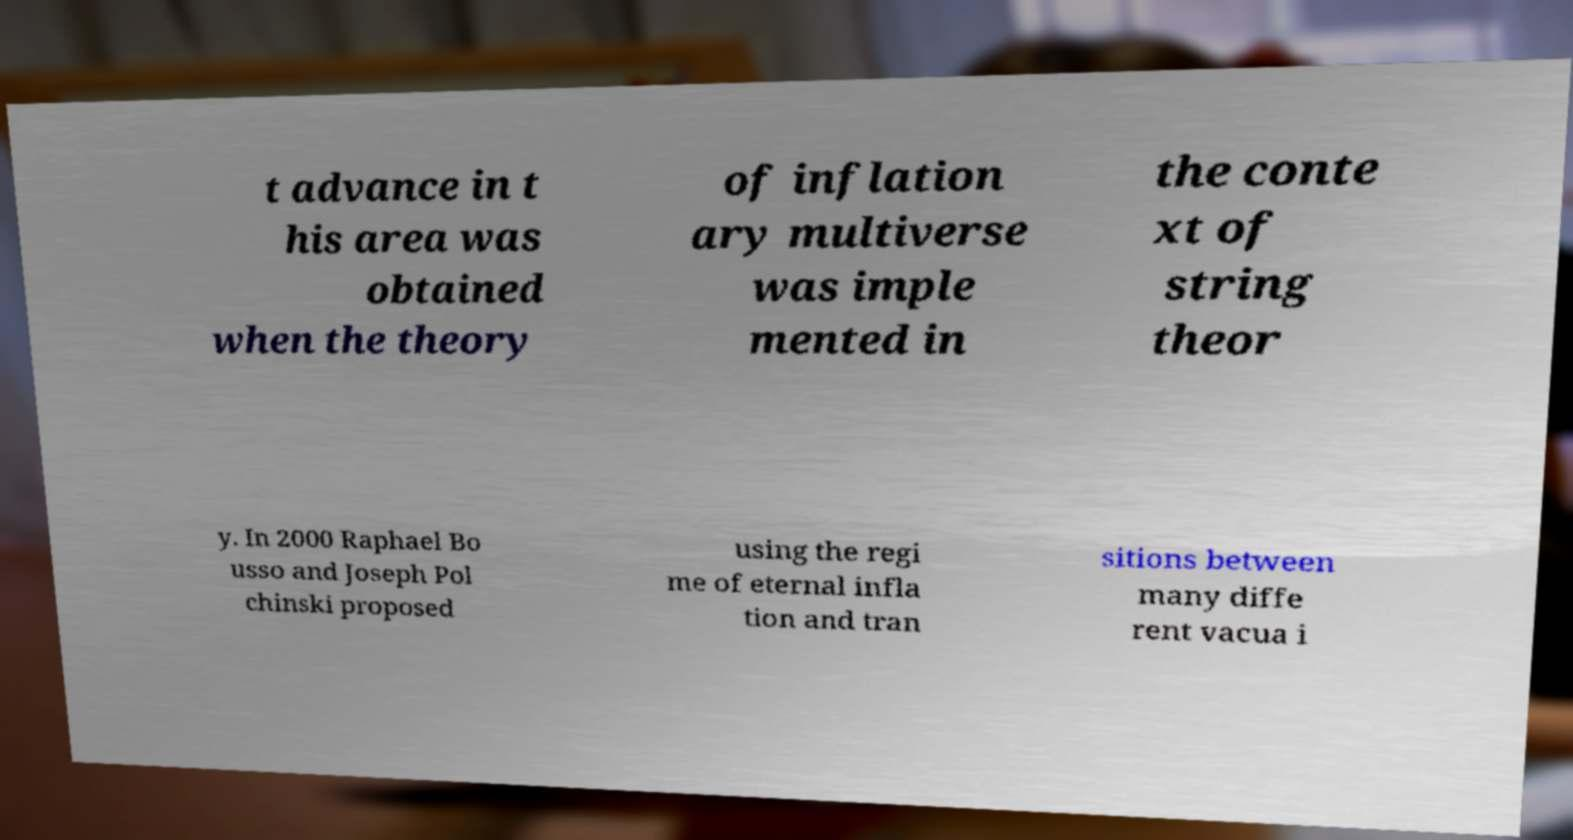What messages or text are displayed in this image? I need them in a readable, typed format. t advance in t his area was obtained when the theory of inflation ary multiverse was imple mented in the conte xt of string theor y. In 2000 Raphael Bo usso and Joseph Pol chinski proposed using the regi me of eternal infla tion and tran sitions between many diffe rent vacua i 